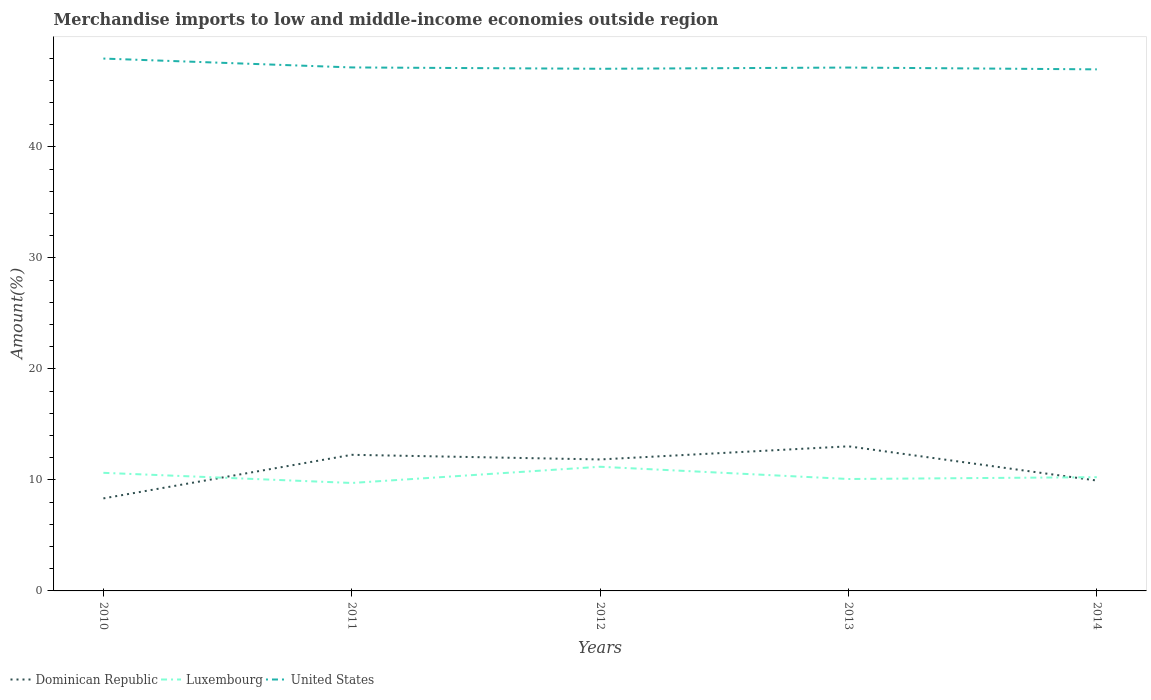Is the number of lines equal to the number of legend labels?
Provide a succinct answer. Yes. Across all years, what is the maximum percentage of amount earned from merchandise imports in United States?
Ensure brevity in your answer.  46.98. What is the total percentage of amount earned from merchandise imports in Dominican Republic in the graph?
Keep it short and to the point. -1.18. What is the difference between the highest and the second highest percentage of amount earned from merchandise imports in Luxembourg?
Offer a very short reply. 1.46. Is the percentage of amount earned from merchandise imports in Luxembourg strictly greater than the percentage of amount earned from merchandise imports in United States over the years?
Offer a very short reply. Yes. How many years are there in the graph?
Offer a terse response. 5. What is the difference between two consecutive major ticks on the Y-axis?
Keep it short and to the point. 10. Are the values on the major ticks of Y-axis written in scientific E-notation?
Offer a very short reply. No. Does the graph contain any zero values?
Offer a terse response. No. Does the graph contain grids?
Offer a very short reply. No. What is the title of the graph?
Ensure brevity in your answer.  Merchandise imports to low and middle-income economies outside region. Does "Latin America(developing only)" appear as one of the legend labels in the graph?
Keep it short and to the point. No. What is the label or title of the X-axis?
Provide a succinct answer. Years. What is the label or title of the Y-axis?
Keep it short and to the point. Amount(%). What is the Amount(%) in Dominican Republic in 2010?
Your answer should be compact. 8.33. What is the Amount(%) of Luxembourg in 2010?
Keep it short and to the point. 10.64. What is the Amount(%) of United States in 2010?
Give a very brief answer. 47.95. What is the Amount(%) of Dominican Republic in 2011?
Your answer should be compact. 12.26. What is the Amount(%) in Luxembourg in 2011?
Offer a very short reply. 9.72. What is the Amount(%) in United States in 2011?
Provide a short and direct response. 47.15. What is the Amount(%) in Dominican Republic in 2012?
Give a very brief answer. 11.84. What is the Amount(%) of Luxembourg in 2012?
Your answer should be very brief. 11.18. What is the Amount(%) of United States in 2012?
Offer a very short reply. 47.03. What is the Amount(%) of Dominican Republic in 2013?
Your answer should be compact. 13.02. What is the Amount(%) in Luxembourg in 2013?
Make the answer very short. 10.08. What is the Amount(%) of United States in 2013?
Your answer should be very brief. 47.14. What is the Amount(%) in Dominican Republic in 2014?
Your answer should be compact. 9.94. What is the Amount(%) of Luxembourg in 2014?
Ensure brevity in your answer.  10.24. What is the Amount(%) in United States in 2014?
Your response must be concise. 46.98. Across all years, what is the maximum Amount(%) in Dominican Republic?
Give a very brief answer. 13.02. Across all years, what is the maximum Amount(%) of Luxembourg?
Give a very brief answer. 11.18. Across all years, what is the maximum Amount(%) in United States?
Give a very brief answer. 47.95. Across all years, what is the minimum Amount(%) in Dominican Republic?
Ensure brevity in your answer.  8.33. Across all years, what is the minimum Amount(%) in Luxembourg?
Offer a very short reply. 9.72. Across all years, what is the minimum Amount(%) of United States?
Offer a very short reply. 46.98. What is the total Amount(%) in Dominican Republic in the graph?
Keep it short and to the point. 55.4. What is the total Amount(%) of Luxembourg in the graph?
Offer a terse response. 51.87. What is the total Amount(%) in United States in the graph?
Your answer should be very brief. 236.25. What is the difference between the Amount(%) in Dominican Republic in 2010 and that in 2011?
Offer a terse response. -3.93. What is the difference between the Amount(%) of Luxembourg in 2010 and that in 2011?
Provide a succinct answer. 0.91. What is the difference between the Amount(%) of United States in 2010 and that in 2011?
Ensure brevity in your answer.  0.8. What is the difference between the Amount(%) in Dominican Republic in 2010 and that in 2012?
Make the answer very short. -3.51. What is the difference between the Amount(%) in Luxembourg in 2010 and that in 2012?
Provide a succinct answer. -0.55. What is the difference between the Amount(%) in United States in 2010 and that in 2012?
Your response must be concise. 0.92. What is the difference between the Amount(%) in Dominican Republic in 2010 and that in 2013?
Ensure brevity in your answer.  -4.69. What is the difference between the Amount(%) in Luxembourg in 2010 and that in 2013?
Your answer should be very brief. 0.56. What is the difference between the Amount(%) in United States in 2010 and that in 2013?
Ensure brevity in your answer.  0.81. What is the difference between the Amount(%) in Dominican Republic in 2010 and that in 2014?
Provide a short and direct response. -1.61. What is the difference between the Amount(%) of Luxembourg in 2010 and that in 2014?
Offer a very short reply. 0.39. What is the difference between the Amount(%) in United States in 2010 and that in 2014?
Ensure brevity in your answer.  0.97. What is the difference between the Amount(%) of Dominican Republic in 2011 and that in 2012?
Make the answer very short. 0.42. What is the difference between the Amount(%) of Luxembourg in 2011 and that in 2012?
Provide a succinct answer. -1.46. What is the difference between the Amount(%) of United States in 2011 and that in 2012?
Your answer should be very brief. 0.12. What is the difference between the Amount(%) of Dominican Republic in 2011 and that in 2013?
Offer a terse response. -0.76. What is the difference between the Amount(%) in Luxembourg in 2011 and that in 2013?
Give a very brief answer. -0.36. What is the difference between the Amount(%) in United States in 2011 and that in 2013?
Provide a short and direct response. 0.01. What is the difference between the Amount(%) in Dominican Republic in 2011 and that in 2014?
Offer a very short reply. 2.32. What is the difference between the Amount(%) in Luxembourg in 2011 and that in 2014?
Your answer should be compact. -0.52. What is the difference between the Amount(%) of United States in 2011 and that in 2014?
Ensure brevity in your answer.  0.17. What is the difference between the Amount(%) in Dominican Republic in 2012 and that in 2013?
Your answer should be compact. -1.18. What is the difference between the Amount(%) in Luxembourg in 2012 and that in 2013?
Keep it short and to the point. 1.1. What is the difference between the Amount(%) in United States in 2012 and that in 2013?
Provide a short and direct response. -0.11. What is the difference between the Amount(%) of Dominican Republic in 2012 and that in 2014?
Your answer should be compact. 1.9. What is the difference between the Amount(%) of Luxembourg in 2012 and that in 2014?
Ensure brevity in your answer.  0.94. What is the difference between the Amount(%) in United States in 2012 and that in 2014?
Provide a short and direct response. 0.05. What is the difference between the Amount(%) of Dominican Republic in 2013 and that in 2014?
Ensure brevity in your answer.  3.08. What is the difference between the Amount(%) in Luxembourg in 2013 and that in 2014?
Keep it short and to the point. -0.16. What is the difference between the Amount(%) of United States in 2013 and that in 2014?
Provide a short and direct response. 0.16. What is the difference between the Amount(%) of Dominican Republic in 2010 and the Amount(%) of Luxembourg in 2011?
Make the answer very short. -1.39. What is the difference between the Amount(%) in Dominican Republic in 2010 and the Amount(%) in United States in 2011?
Offer a terse response. -38.82. What is the difference between the Amount(%) of Luxembourg in 2010 and the Amount(%) of United States in 2011?
Your answer should be very brief. -36.52. What is the difference between the Amount(%) in Dominican Republic in 2010 and the Amount(%) in Luxembourg in 2012?
Offer a very short reply. -2.85. What is the difference between the Amount(%) of Dominican Republic in 2010 and the Amount(%) of United States in 2012?
Make the answer very short. -38.7. What is the difference between the Amount(%) in Luxembourg in 2010 and the Amount(%) in United States in 2012?
Give a very brief answer. -36.39. What is the difference between the Amount(%) in Dominican Republic in 2010 and the Amount(%) in Luxembourg in 2013?
Ensure brevity in your answer.  -1.75. What is the difference between the Amount(%) of Dominican Republic in 2010 and the Amount(%) of United States in 2013?
Provide a succinct answer. -38.81. What is the difference between the Amount(%) of Luxembourg in 2010 and the Amount(%) of United States in 2013?
Provide a short and direct response. -36.5. What is the difference between the Amount(%) in Dominican Republic in 2010 and the Amount(%) in Luxembourg in 2014?
Offer a very short reply. -1.91. What is the difference between the Amount(%) in Dominican Republic in 2010 and the Amount(%) in United States in 2014?
Keep it short and to the point. -38.64. What is the difference between the Amount(%) of Luxembourg in 2010 and the Amount(%) of United States in 2014?
Your answer should be compact. -36.34. What is the difference between the Amount(%) of Dominican Republic in 2011 and the Amount(%) of Luxembourg in 2012?
Your answer should be compact. 1.08. What is the difference between the Amount(%) of Dominican Republic in 2011 and the Amount(%) of United States in 2012?
Your answer should be very brief. -34.77. What is the difference between the Amount(%) of Luxembourg in 2011 and the Amount(%) of United States in 2012?
Your response must be concise. -37.31. What is the difference between the Amount(%) in Dominican Republic in 2011 and the Amount(%) in Luxembourg in 2013?
Your answer should be very brief. 2.18. What is the difference between the Amount(%) in Dominican Republic in 2011 and the Amount(%) in United States in 2013?
Keep it short and to the point. -34.88. What is the difference between the Amount(%) in Luxembourg in 2011 and the Amount(%) in United States in 2013?
Make the answer very short. -37.42. What is the difference between the Amount(%) in Dominican Republic in 2011 and the Amount(%) in Luxembourg in 2014?
Make the answer very short. 2.02. What is the difference between the Amount(%) of Dominican Republic in 2011 and the Amount(%) of United States in 2014?
Provide a short and direct response. -34.72. What is the difference between the Amount(%) of Luxembourg in 2011 and the Amount(%) of United States in 2014?
Give a very brief answer. -37.26. What is the difference between the Amount(%) in Dominican Republic in 2012 and the Amount(%) in Luxembourg in 2013?
Your answer should be compact. 1.76. What is the difference between the Amount(%) of Dominican Republic in 2012 and the Amount(%) of United States in 2013?
Your answer should be compact. -35.3. What is the difference between the Amount(%) in Luxembourg in 2012 and the Amount(%) in United States in 2013?
Provide a short and direct response. -35.96. What is the difference between the Amount(%) of Dominican Republic in 2012 and the Amount(%) of Luxembourg in 2014?
Offer a terse response. 1.6. What is the difference between the Amount(%) of Dominican Republic in 2012 and the Amount(%) of United States in 2014?
Provide a short and direct response. -35.14. What is the difference between the Amount(%) in Luxembourg in 2012 and the Amount(%) in United States in 2014?
Offer a terse response. -35.79. What is the difference between the Amount(%) of Dominican Republic in 2013 and the Amount(%) of Luxembourg in 2014?
Offer a very short reply. 2.78. What is the difference between the Amount(%) of Dominican Republic in 2013 and the Amount(%) of United States in 2014?
Offer a very short reply. -33.95. What is the difference between the Amount(%) of Luxembourg in 2013 and the Amount(%) of United States in 2014?
Ensure brevity in your answer.  -36.9. What is the average Amount(%) in Dominican Republic per year?
Offer a terse response. 11.08. What is the average Amount(%) of Luxembourg per year?
Offer a terse response. 10.37. What is the average Amount(%) of United States per year?
Make the answer very short. 47.25. In the year 2010, what is the difference between the Amount(%) in Dominican Republic and Amount(%) in Luxembourg?
Offer a terse response. -2.3. In the year 2010, what is the difference between the Amount(%) of Dominican Republic and Amount(%) of United States?
Provide a succinct answer. -39.62. In the year 2010, what is the difference between the Amount(%) in Luxembourg and Amount(%) in United States?
Provide a succinct answer. -37.31. In the year 2011, what is the difference between the Amount(%) in Dominican Republic and Amount(%) in Luxembourg?
Give a very brief answer. 2.54. In the year 2011, what is the difference between the Amount(%) in Dominican Republic and Amount(%) in United States?
Offer a very short reply. -34.89. In the year 2011, what is the difference between the Amount(%) of Luxembourg and Amount(%) of United States?
Make the answer very short. -37.43. In the year 2012, what is the difference between the Amount(%) of Dominican Republic and Amount(%) of Luxembourg?
Provide a short and direct response. 0.66. In the year 2012, what is the difference between the Amount(%) of Dominican Republic and Amount(%) of United States?
Offer a very short reply. -35.19. In the year 2012, what is the difference between the Amount(%) of Luxembourg and Amount(%) of United States?
Provide a short and direct response. -35.85. In the year 2013, what is the difference between the Amount(%) in Dominican Republic and Amount(%) in Luxembourg?
Provide a succinct answer. 2.94. In the year 2013, what is the difference between the Amount(%) of Dominican Republic and Amount(%) of United States?
Offer a very short reply. -34.12. In the year 2013, what is the difference between the Amount(%) in Luxembourg and Amount(%) in United States?
Ensure brevity in your answer.  -37.06. In the year 2014, what is the difference between the Amount(%) in Dominican Republic and Amount(%) in Luxembourg?
Offer a very short reply. -0.3. In the year 2014, what is the difference between the Amount(%) of Dominican Republic and Amount(%) of United States?
Provide a succinct answer. -37.04. In the year 2014, what is the difference between the Amount(%) in Luxembourg and Amount(%) in United States?
Give a very brief answer. -36.73. What is the ratio of the Amount(%) in Dominican Republic in 2010 to that in 2011?
Provide a short and direct response. 0.68. What is the ratio of the Amount(%) of Luxembourg in 2010 to that in 2011?
Provide a succinct answer. 1.09. What is the ratio of the Amount(%) of United States in 2010 to that in 2011?
Your answer should be compact. 1.02. What is the ratio of the Amount(%) of Dominican Republic in 2010 to that in 2012?
Your answer should be compact. 0.7. What is the ratio of the Amount(%) of Luxembourg in 2010 to that in 2012?
Provide a succinct answer. 0.95. What is the ratio of the Amount(%) of United States in 2010 to that in 2012?
Your answer should be compact. 1.02. What is the ratio of the Amount(%) of Dominican Republic in 2010 to that in 2013?
Your answer should be compact. 0.64. What is the ratio of the Amount(%) in Luxembourg in 2010 to that in 2013?
Make the answer very short. 1.06. What is the ratio of the Amount(%) of United States in 2010 to that in 2013?
Offer a terse response. 1.02. What is the ratio of the Amount(%) in Dominican Republic in 2010 to that in 2014?
Offer a terse response. 0.84. What is the ratio of the Amount(%) in Luxembourg in 2010 to that in 2014?
Keep it short and to the point. 1.04. What is the ratio of the Amount(%) of United States in 2010 to that in 2014?
Your answer should be compact. 1.02. What is the ratio of the Amount(%) in Dominican Republic in 2011 to that in 2012?
Offer a very short reply. 1.04. What is the ratio of the Amount(%) of Luxembourg in 2011 to that in 2012?
Offer a terse response. 0.87. What is the ratio of the Amount(%) in Dominican Republic in 2011 to that in 2013?
Your answer should be very brief. 0.94. What is the ratio of the Amount(%) of Luxembourg in 2011 to that in 2013?
Your response must be concise. 0.96. What is the ratio of the Amount(%) of United States in 2011 to that in 2013?
Keep it short and to the point. 1. What is the ratio of the Amount(%) of Dominican Republic in 2011 to that in 2014?
Make the answer very short. 1.23. What is the ratio of the Amount(%) of Luxembourg in 2011 to that in 2014?
Make the answer very short. 0.95. What is the ratio of the Amount(%) in United States in 2011 to that in 2014?
Ensure brevity in your answer.  1. What is the ratio of the Amount(%) in Dominican Republic in 2012 to that in 2013?
Offer a very short reply. 0.91. What is the ratio of the Amount(%) of Luxembourg in 2012 to that in 2013?
Ensure brevity in your answer.  1.11. What is the ratio of the Amount(%) of Dominican Republic in 2012 to that in 2014?
Your answer should be compact. 1.19. What is the ratio of the Amount(%) in Luxembourg in 2012 to that in 2014?
Your response must be concise. 1.09. What is the ratio of the Amount(%) in United States in 2012 to that in 2014?
Ensure brevity in your answer.  1. What is the ratio of the Amount(%) of Dominican Republic in 2013 to that in 2014?
Offer a terse response. 1.31. What is the ratio of the Amount(%) in Luxembourg in 2013 to that in 2014?
Ensure brevity in your answer.  0.98. What is the difference between the highest and the second highest Amount(%) of Dominican Republic?
Offer a very short reply. 0.76. What is the difference between the highest and the second highest Amount(%) of Luxembourg?
Offer a terse response. 0.55. What is the difference between the highest and the second highest Amount(%) in United States?
Provide a short and direct response. 0.8. What is the difference between the highest and the lowest Amount(%) of Dominican Republic?
Ensure brevity in your answer.  4.69. What is the difference between the highest and the lowest Amount(%) in Luxembourg?
Provide a short and direct response. 1.46. What is the difference between the highest and the lowest Amount(%) of United States?
Make the answer very short. 0.97. 